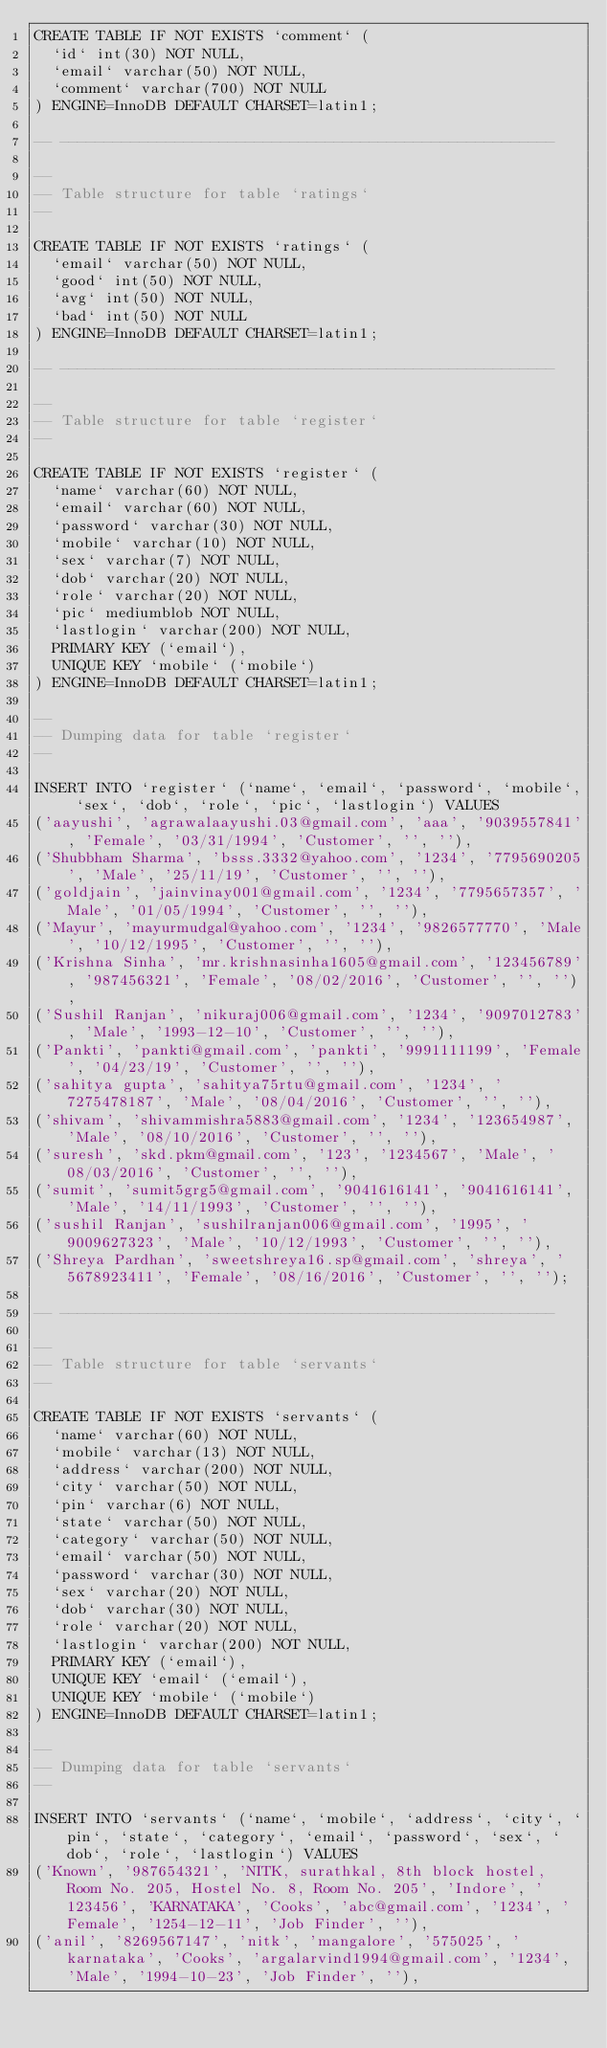Convert code to text. <code><loc_0><loc_0><loc_500><loc_500><_SQL_>CREATE TABLE IF NOT EXISTS `comment` (
  `id` int(30) NOT NULL,
  `email` varchar(50) NOT NULL,
  `comment` varchar(700) NOT NULL
) ENGINE=InnoDB DEFAULT CHARSET=latin1;

-- --------------------------------------------------------

--
-- Table structure for table `ratings`
--

CREATE TABLE IF NOT EXISTS `ratings` (
  `email` varchar(50) NOT NULL,
  `good` int(50) NOT NULL,
  `avg` int(50) NOT NULL,
  `bad` int(50) NOT NULL
) ENGINE=InnoDB DEFAULT CHARSET=latin1;

-- --------------------------------------------------------

--
-- Table structure for table `register`
--

CREATE TABLE IF NOT EXISTS `register` (
  `name` varchar(60) NOT NULL,
  `email` varchar(60) NOT NULL,
  `password` varchar(30) NOT NULL,
  `mobile` varchar(10) NOT NULL,
  `sex` varchar(7) NOT NULL,
  `dob` varchar(20) NOT NULL,
  `role` varchar(20) NOT NULL,
  `pic` mediumblob NOT NULL,
  `lastlogin` varchar(200) NOT NULL,
  PRIMARY KEY (`email`),
  UNIQUE KEY `mobile` (`mobile`)
) ENGINE=InnoDB DEFAULT CHARSET=latin1;

--
-- Dumping data for table `register`
--

INSERT INTO `register` (`name`, `email`, `password`, `mobile`, `sex`, `dob`, `role`, `pic`, `lastlogin`) VALUES
('aayushi', 'agrawalaayushi.03@gmail.com', 'aaa', '9039557841', 'Female', '03/31/1994', 'Customer', '', ''),
('Shubbham Sharma', 'bsss.3332@yahoo.com', '1234', '7795690205', 'Male', '25/11/19', 'Customer', '', ''),
('goldjain', 'jainvinay001@gmail.com', '1234', '7795657357', 'Male', '01/05/1994', 'Customer', '', ''),
('Mayur', 'mayurmudgal@yahoo.com', '1234', '9826577770', 'Male', '10/12/1995', 'Customer', '', ''),
('Krishna Sinha', 'mr.krishnasinha1605@gmail.com', '123456789', '987456321', 'Female', '08/02/2016', 'Customer', '', ''),
('Sushil Ranjan', 'nikuraj006@gmail.com', '1234', '9097012783', 'Male', '1993-12-10', 'Customer', '', ''),
('Pankti', 'pankti@gmail.com', 'pankti', '9991111199', 'Female', '04/23/19', 'Customer', '', ''),
('sahitya gupta', 'sahitya75rtu@gmail.com', '1234', '7275478187', 'Male', '08/04/2016', 'Customer', '', ''),
('shivam', 'shivammishra5883@gmail.com', '1234', '123654987', 'Male', '08/10/2016', 'Customer', '', ''),
('suresh', 'skd.pkm@gmail.com', '123', '1234567', 'Male', '08/03/2016', 'Customer', '', ''),
('sumit', 'sumit5grg5@gmail.com', '9041616141', '9041616141', 'Male', '14/11/1993', 'Customer', '', ''),
('sushil Ranjan', 'sushilranjan006@gmail.com', '1995', '9009627323', 'Male', '10/12/1993', 'Customer', '', ''),
('Shreya Pardhan', 'sweetshreya16.sp@gmail.com', 'shreya', '5678923411', 'Female', '08/16/2016', 'Customer', '', '');

-- --------------------------------------------------------

--
-- Table structure for table `servants`
--

CREATE TABLE IF NOT EXISTS `servants` (
  `name` varchar(60) NOT NULL,
  `mobile` varchar(13) NOT NULL,
  `address` varchar(200) NOT NULL,
  `city` varchar(50) NOT NULL,
  `pin` varchar(6) NOT NULL,
  `state` varchar(50) NOT NULL,
  `category` varchar(50) NOT NULL,
  `email` varchar(50) NOT NULL,
  `password` varchar(30) NOT NULL,
  `sex` varchar(20) NOT NULL,
  `dob` varchar(30) NOT NULL,
  `role` varchar(20) NOT NULL,
  `lastlogin` varchar(200) NOT NULL,
  PRIMARY KEY (`email`),
  UNIQUE KEY `email` (`email`),
  UNIQUE KEY `mobile` (`mobile`)
) ENGINE=InnoDB DEFAULT CHARSET=latin1;

--
-- Dumping data for table `servants`
--

INSERT INTO `servants` (`name`, `mobile`, `address`, `city`, `pin`, `state`, `category`, `email`, `password`, `sex`, `dob`, `role`, `lastlogin`) VALUES
('Known', '987654321', 'NITK, surathkal, 8th block hostel, Room No. 205, Hostel No. 8, Room No. 205', 'Indore', '123456', 'KARNATAKA', 'Cooks', 'abc@gmail.com', '1234', 'Female', '1254-12-11', 'Job Finder', ''),
('anil', '8269567147', 'nitk', 'mangalore', '575025', 'karnataka', 'Cooks', 'argalarvind1994@gmail.com', '1234', 'Male', '1994-10-23', 'Job Finder', ''),</code> 